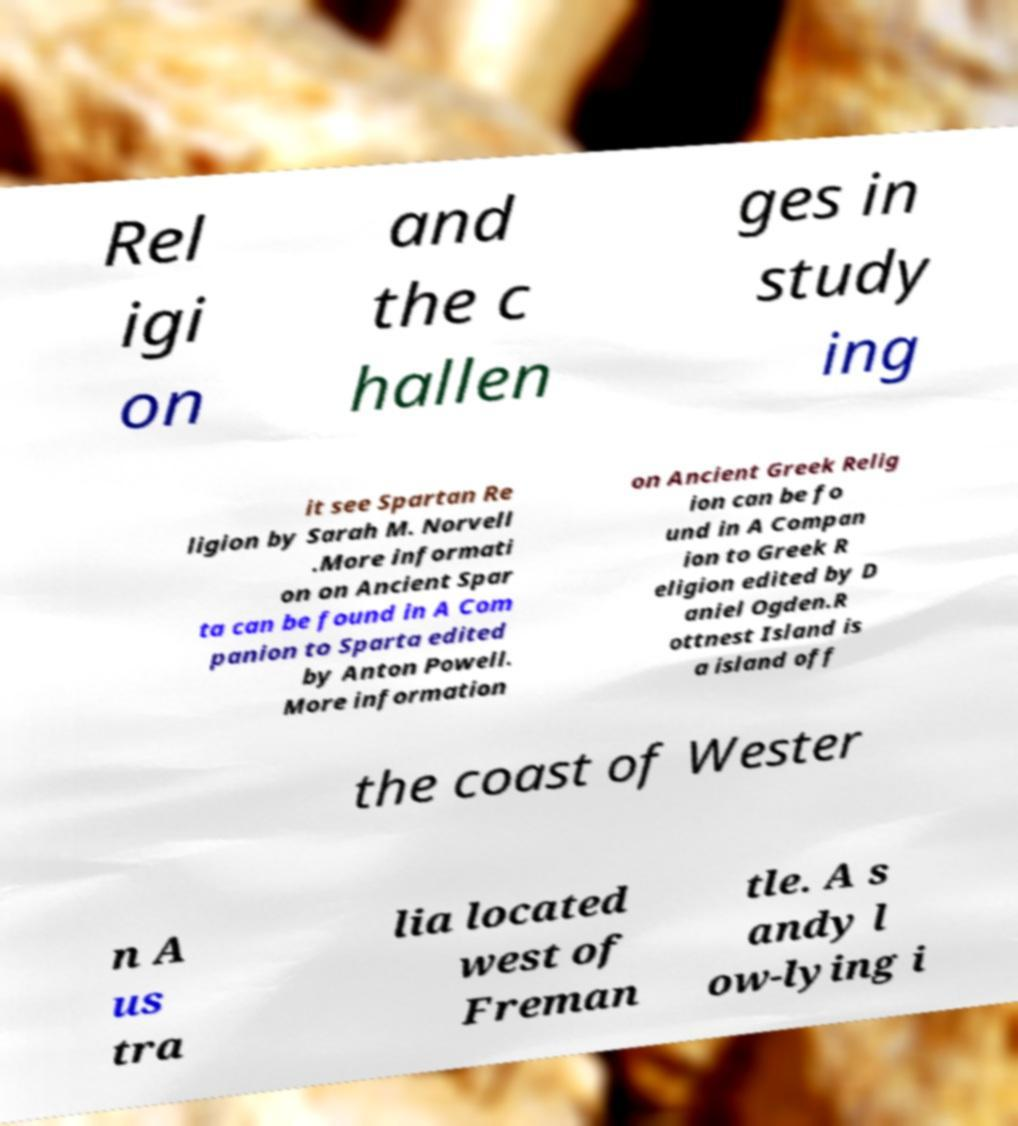I need the written content from this picture converted into text. Can you do that? Rel igi on and the c hallen ges in study ing it see Spartan Re ligion by Sarah M. Norvell .More informati on on Ancient Spar ta can be found in A Com panion to Sparta edited by Anton Powell. More information on Ancient Greek Relig ion can be fo und in A Compan ion to Greek R eligion edited by D aniel Ogden.R ottnest Island is a island off the coast of Wester n A us tra lia located west of Freman tle. A s andy l ow-lying i 